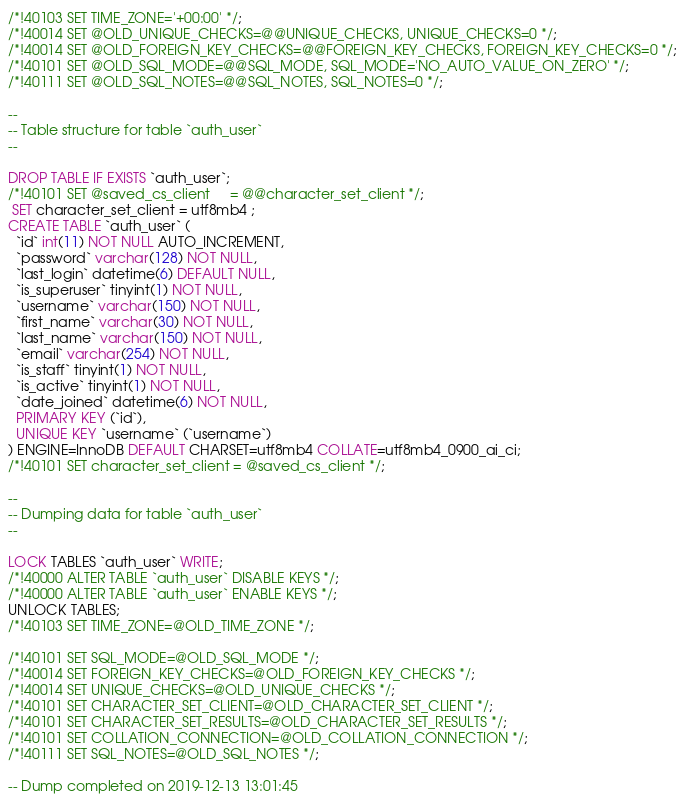<code> <loc_0><loc_0><loc_500><loc_500><_SQL_>/*!40103 SET TIME_ZONE='+00:00' */;
/*!40014 SET @OLD_UNIQUE_CHECKS=@@UNIQUE_CHECKS, UNIQUE_CHECKS=0 */;
/*!40014 SET @OLD_FOREIGN_KEY_CHECKS=@@FOREIGN_KEY_CHECKS, FOREIGN_KEY_CHECKS=0 */;
/*!40101 SET @OLD_SQL_MODE=@@SQL_MODE, SQL_MODE='NO_AUTO_VALUE_ON_ZERO' */;
/*!40111 SET @OLD_SQL_NOTES=@@SQL_NOTES, SQL_NOTES=0 */;

--
-- Table structure for table `auth_user`
--

DROP TABLE IF EXISTS `auth_user`;
/*!40101 SET @saved_cs_client     = @@character_set_client */;
 SET character_set_client = utf8mb4 ;
CREATE TABLE `auth_user` (
  `id` int(11) NOT NULL AUTO_INCREMENT,
  `password` varchar(128) NOT NULL,
  `last_login` datetime(6) DEFAULT NULL,
  `is_superuser` tinyint(1) NOT NULL,
  `username` varchar(150) NOT NULL,
  `first_name` varchar(30) NOT NULL,
  `last_name` varchar(150) NOT NULL,
  `email` varchar(254) NOT NULL,
  `is_staff` tinyint(1) NOT NULL,
  `is_active` tinyint(1) NOT NULL,
  `date_joined` datetime(6) NOT NULL,
  PRIMARY KEY (`id`),
  UNIQUE KEY `username` (`username`)
) ENGINE=InnoDB DEFAULT CHARSET=utf8mb4 COLLATE=utf8mb4_0900_ai_ci;
/*!40101 SET character_set_client = @saved_cs_client */;

--
-- Dumping data for table `auth_user`
--

LOCK TABLES `auth_user` WRITE;
/*!40000 ALTER TABLE `auth_user` DISABLE KEYS */;
/*!40000 ALTER TABLE `auth_user` ENABLE KEYS */;
UNLOCK TABLES;
/*!40103 SET TIME_ZONE=@OLD_TIME_ZONE */;

/*!40101 SET SQL_MODE=@OLD_SQL_MODE */;
/*!40014 SET FOREIGN_KEY_CHECKS=@OLD_FOREIGN_KEY_CHECKS */;
/*!40014 SET UNIQUE_CHECKS=@OLD_UNIQUE_CHECKS */;
/*!40101 SET CHARACTER_SET_CLIENT=@OLD_CHARACTER_SET_CLIENT */;
/*!40101 SET CHARACTER_SET_RESULTS=@OLD_CHARACTER_SET_RESULTS */;
/*!40101 SET COLLATION_CONNECTION=@OLD_COLLATION_CONNECTION */;
/*!40111 SET SQL_NOTES=@OLD_SQL_NOTES */;

-- Dump completed on 2019-12-13 13:01:45
</code> 